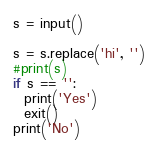<code> <loc_0><loc_0><loc_500><loc_500><_Python_>s = input()

s = s.replace('hi', '')
#print(s)
if s == '':
  print('Yes')
  exit()
print('No')</code> 